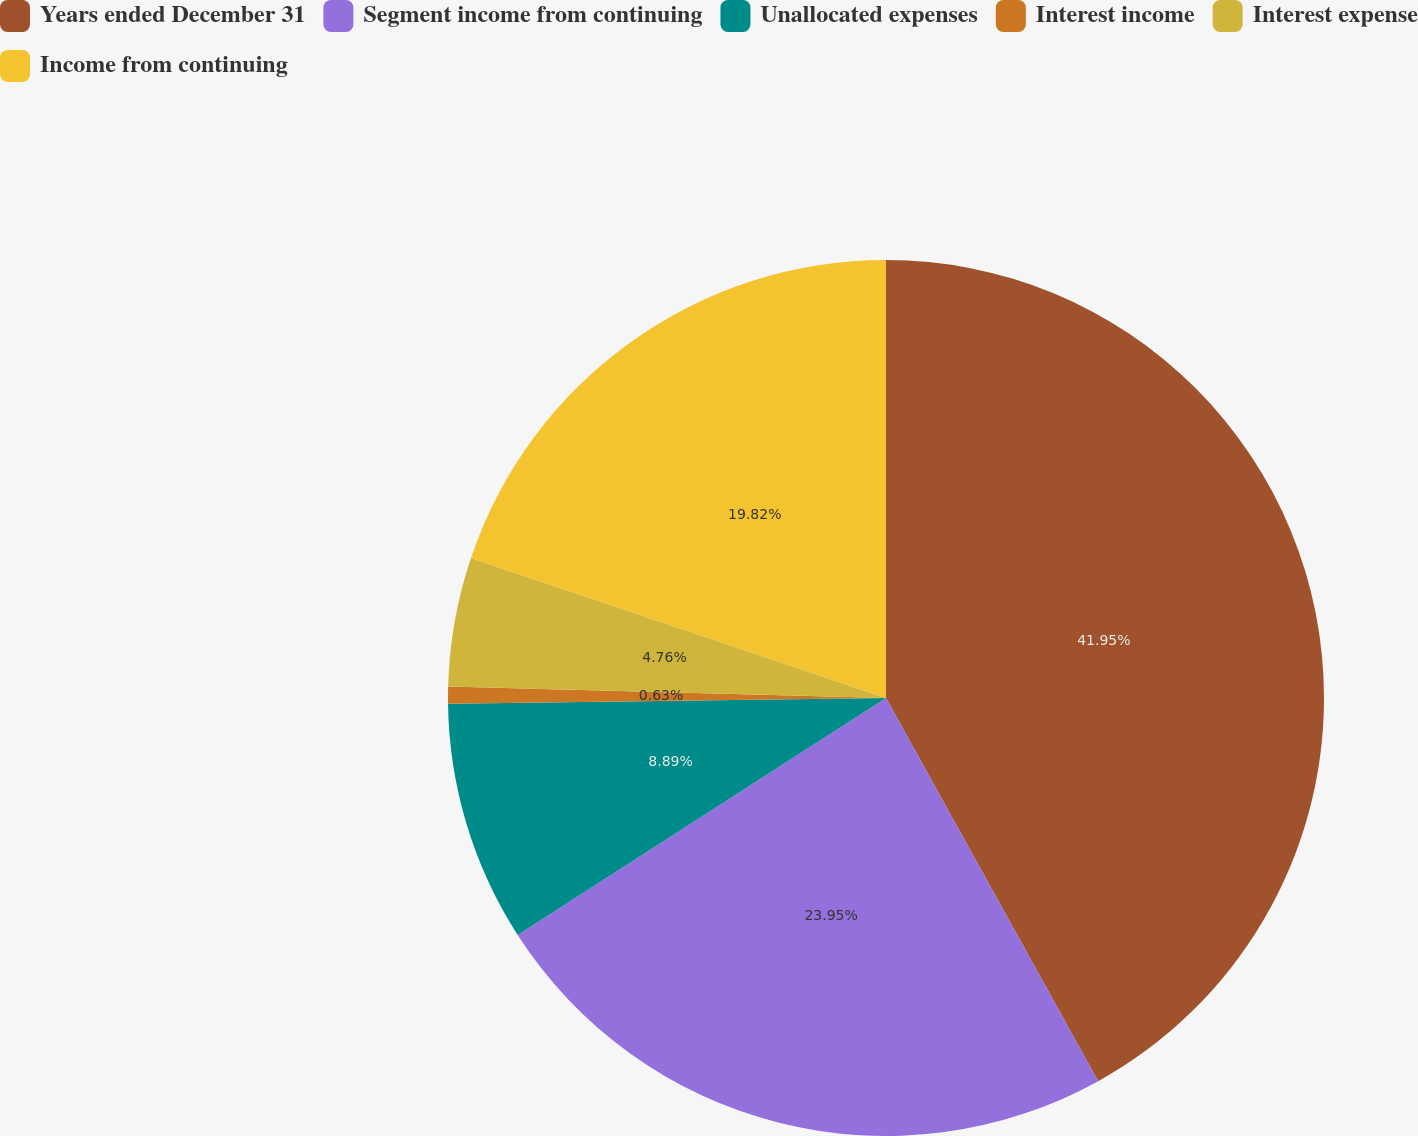Convert chart. <chart><loc_0><loc_0><loc_500><loc_500><pie_chart><fcel>Years ended December 31<fcel>Segment income from continuing<fcel>Unallocated expenses<fcel>Interest income<fcel>Interest expense<fcel>Income from continuing<nl><fcel>41.95%<fcel>23.95%<fcel>8.89%<fcel>0.63%<fcel>4.76%<fcel>19.82%<nl></chart> 